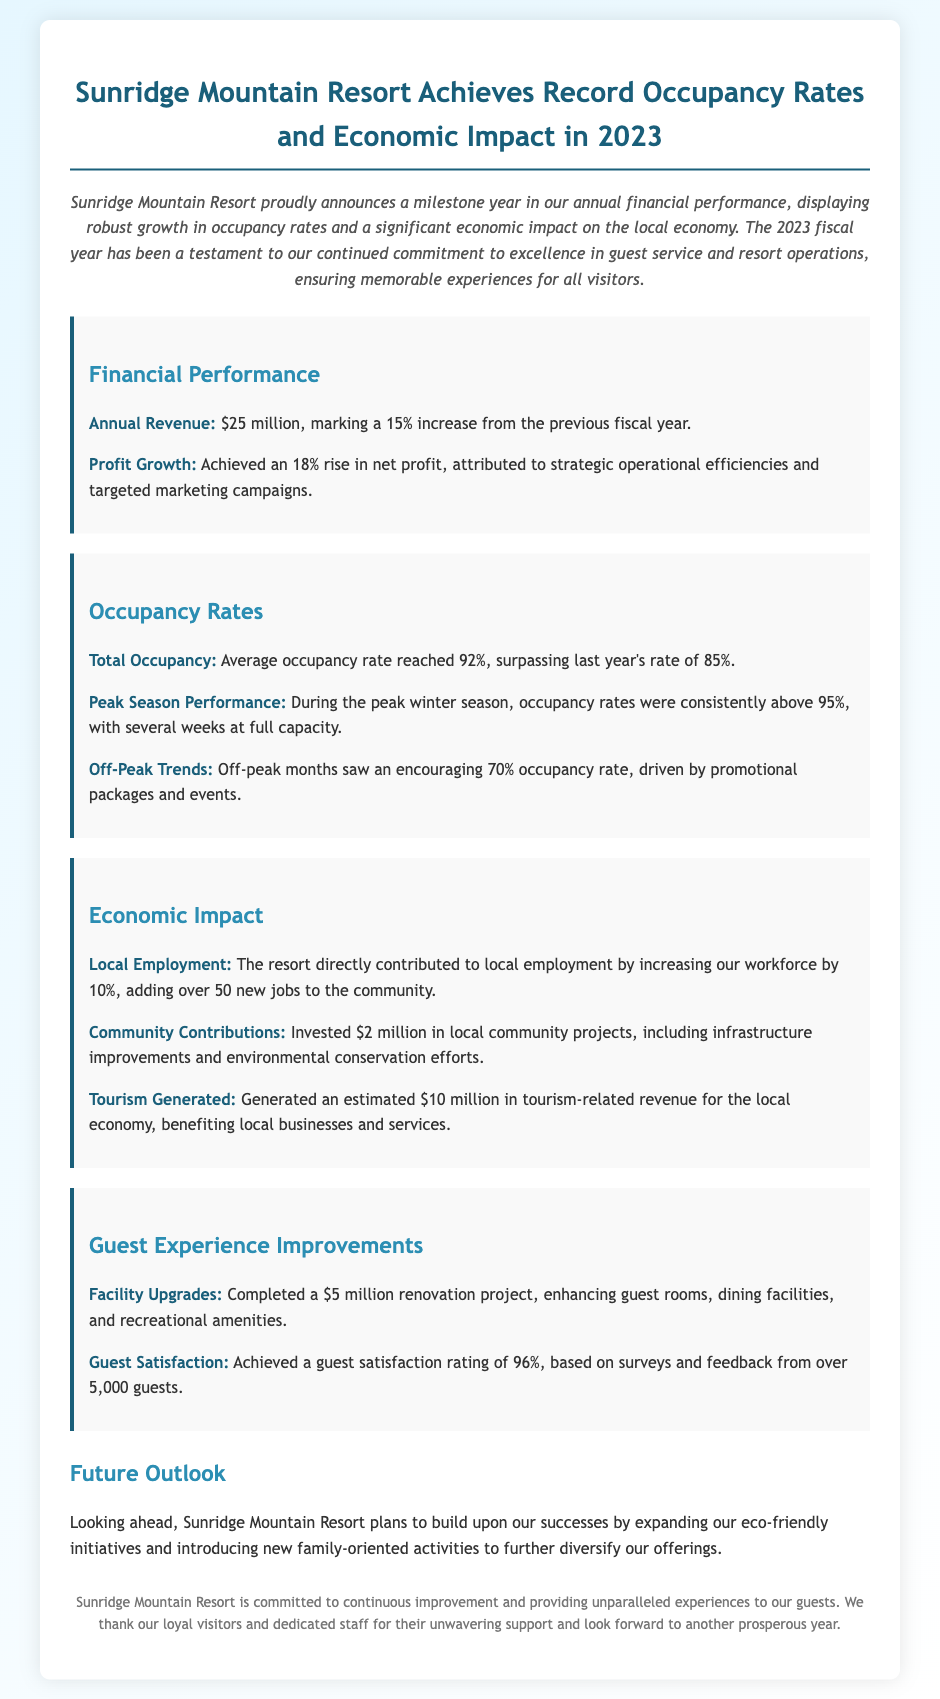What was the annual revenue for 2023? The annual revenue is stated in the document as $25 million, highlighting the financial performance of the resort.
Answer: $25 million What was the average occupancy rate for the year? The document mentions that the average occupancy rate reached 92%, a key performance indicator for the resort.
Answer: 92% How much did the resort invest in local community projects? The document specifies that the resort invested $2 million in local community projects, reflecting its economic impact.
Answer: $2 million What was the guest satisfaction rating? The satisfaction rating is stated as 96%, based on feedback from over 5,000 guests, indicating the quality of guest experience.
Answer: 96% How many new jobs were created by the resort? The document indicates that the resort added over 50 new jobs to the community, showing its contribution to local employment.
Answer: over 50 What was the peak season occupancy rate? The document notes that during the peak winter season, occupancy rates were consistently above 95%, which demonstrates high demand during that period.
Answer: above 95% What percentage increase in profit was achieved? The document highlights an 18% rise in net profit due to operational efficiencies, which showcases the resort's financial growth.
Answer: 18% What renovation amount was spent on facility upgrades? The document mentions a $5 million renovation project, emphasizing improvements made for guest facilities.
Answer: $5 million What future initiative does the resort plan to expand upon? The document states a desire to expand eco-friendly initiatives, indicating a focus on sustainability moving forward.
Answer: eco-friendly initiatives 